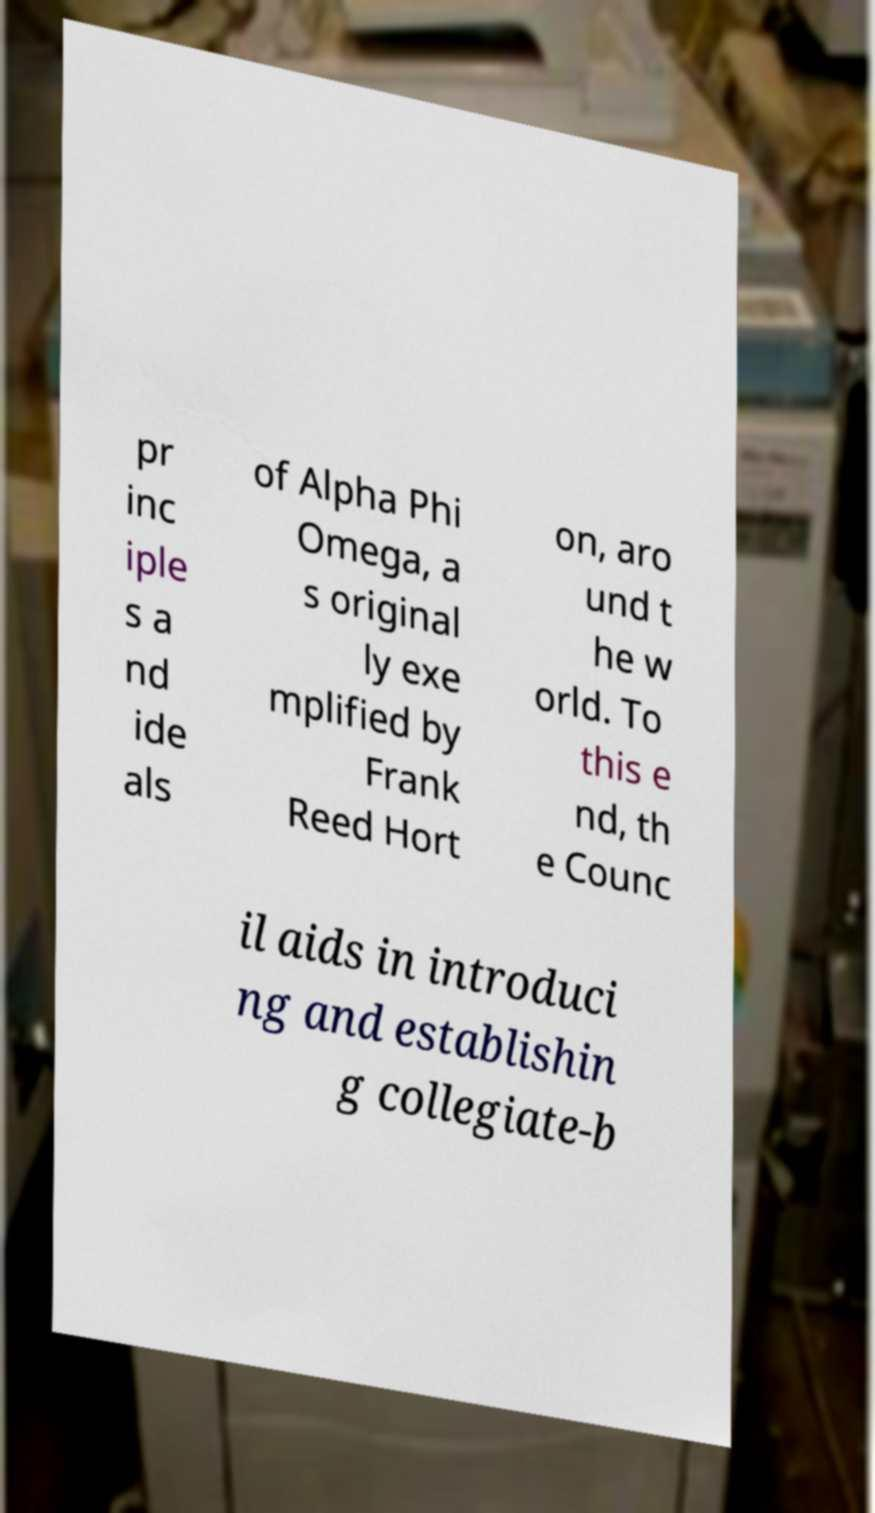Could you extract and type out the text from this image? pr inc iple s a nd ide als of Alpha Phi Omega, a s original ly exe mplified by Frank Reed Hort on, aro und t he w orld. To this e nd, th e Counc il aids in introduci ng and establishin g collegiate-b 